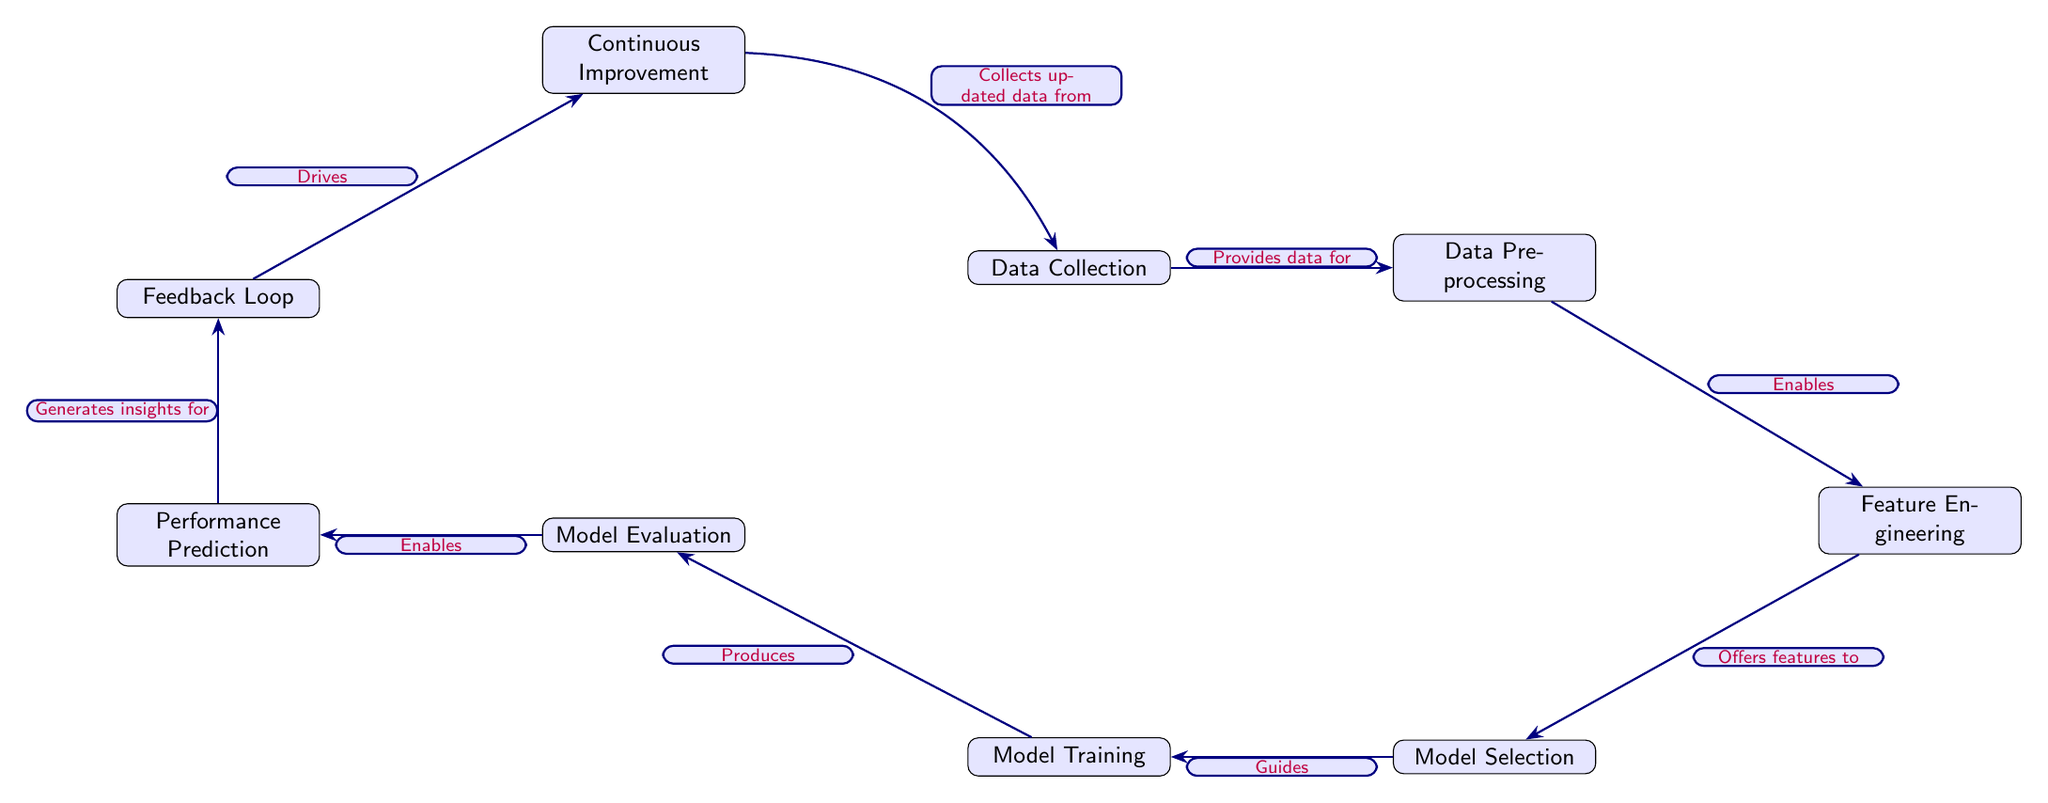What is the first node in the diagram? The first node in the diagram is "Data Collection," which serves as the starting point of the process.
Answer: Data Collection How many nodes are present in the diagram? By counting the labeled nodes in the diagram, we find a total of nine distinct nodes that define the flow of the machine learning process.
Answer: Nine What does "Data Preprocessing" enable? The arrow from "Data Preprocessing" to "Feature Engineering" indicates that it enables feature engineering, showing a direct functional relationship between these two steps.
Answer: Feature Engineering Which node follows "Model Evaluation"? Moving sequentially from "Model Evaluation," the next node is "Performance Prediction," which indicates the outcome of evaluating the model.
Answer: Performance Prediction What type of feedback does the "Feedback Loop" provide? The "Feedback Loop" acts as a driver for "Continuous Improvement," suggesting that it provides insights and data to continuously enhance the performance.
Answer: Drives Which node generates insights for "Feedback Loop"? The arrow from "Performance Prediction" indicates that it generates insights for the "Feedback Loop," linking performance analysis to the iterative process of improvement.
Answer: Performance Prediction What relationship exists between "Continuous Improvement" and "Data Collection"? A bend left arrow from "Continuous Improvement" to "Data Collection" indicates that continuous improvement collects updated data, creating a cyclical relationship in the diagram.
Answer: Collects updated data from How does "Model Training" relate to "Model Selection"? The directional arrow from "Model Selection" to "Model Training" indicates that model selection guides the model training process, signifying reliance on the chosen model.
Answer: Guides What is the purpose of "Feature Engineering"? The purpose of "Feature Engineering" is to offer features to "Model Selection," highlighting its crucial role in preparing inputs for the model choice process.
Answer: Offers features to 